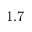<formula> <loc_0><loc_0><loc_500><loc_500>1 . 7</formula> 